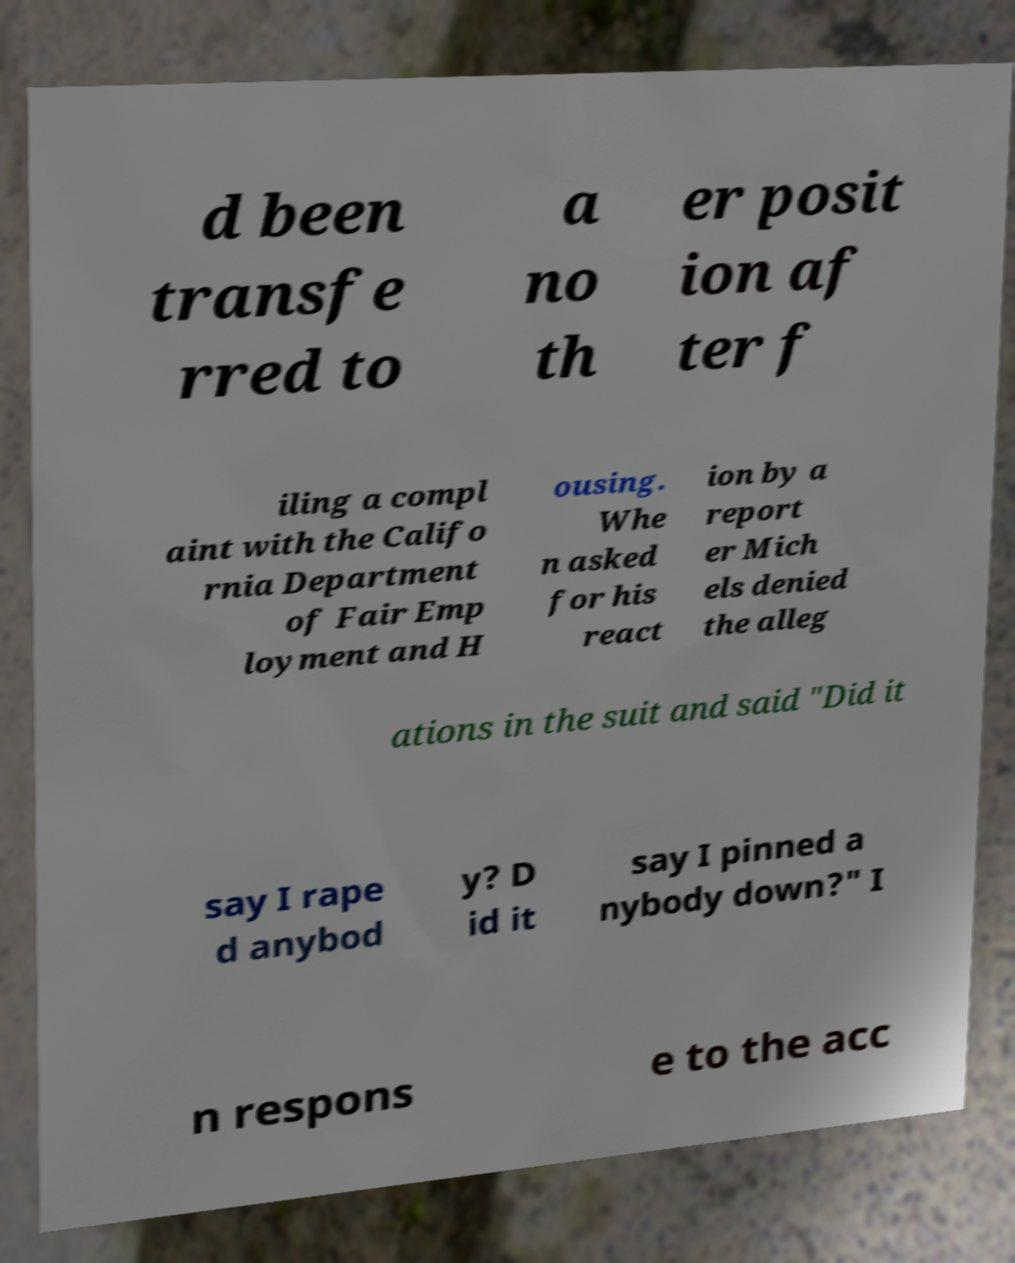Could you assist in decoding the text presented in this image and type it out clearly? d been transfe rred to a no th er posit ion af ter f iling a compl aint with the Califo rnia Department of Fair Emp loyment and H ousing. Whe n asked for his react ion by a report er Mich els denied the alleg ations in the suit and said "Did it say I rape d anybod y? D id it say I pinned a nybody down?" I n respons e to the acc 